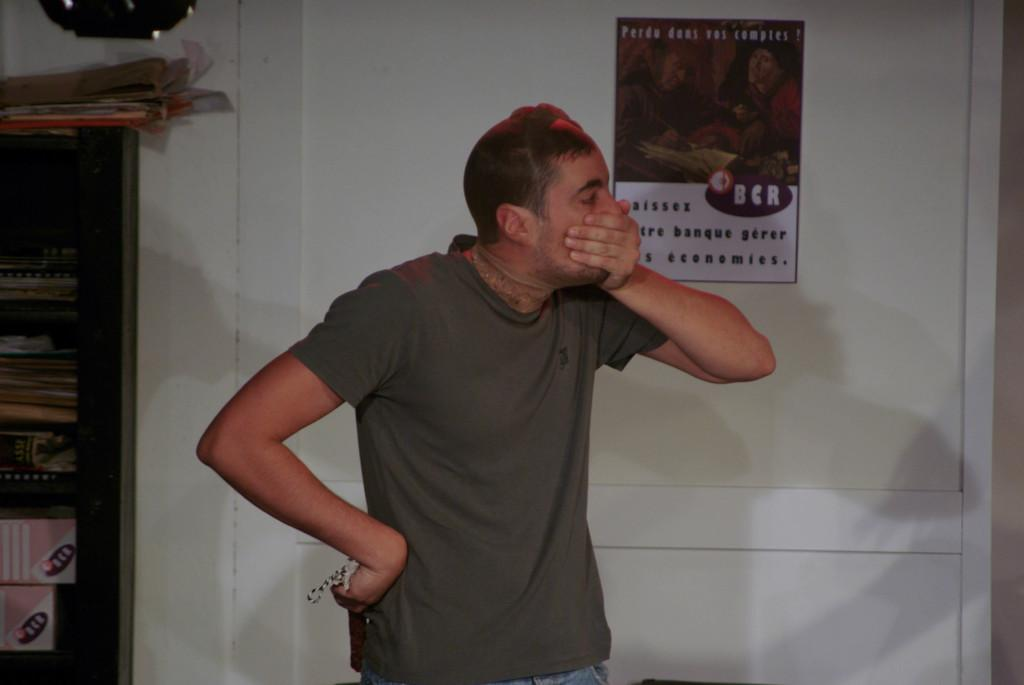<image>
Write a terse but informative summary of the picture. The young man clutching his face stands in front of a door that has a poster with French text. 